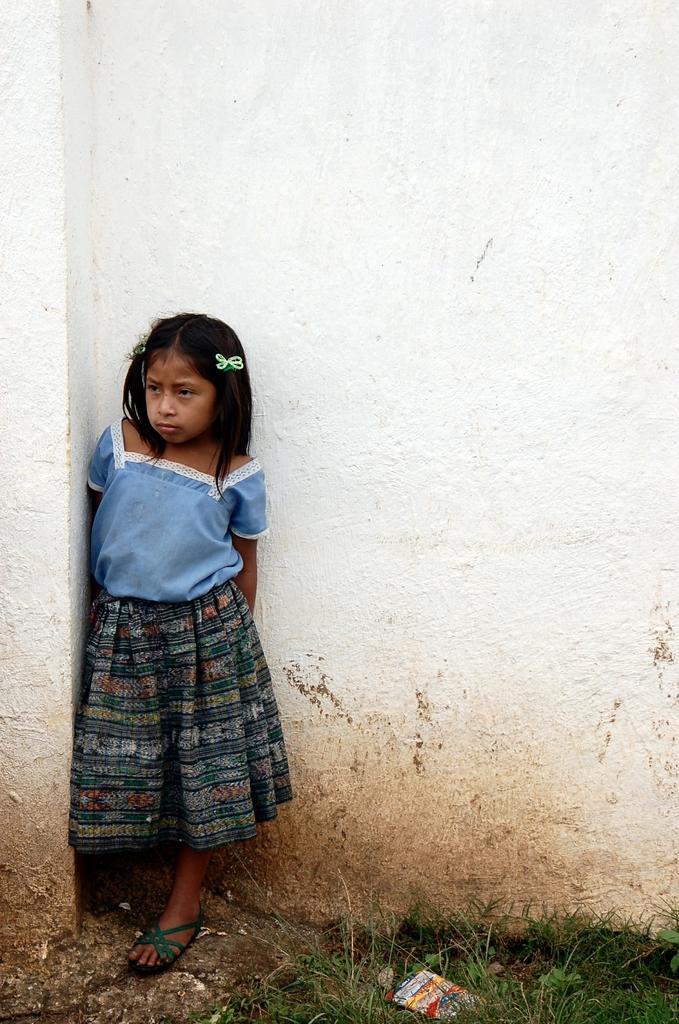How would you summarize this image in a sentence or two? In this image, I can see a girl standing. This is the wall, which is white in color. At the bottom of the image, I can see the grass and a paper. 